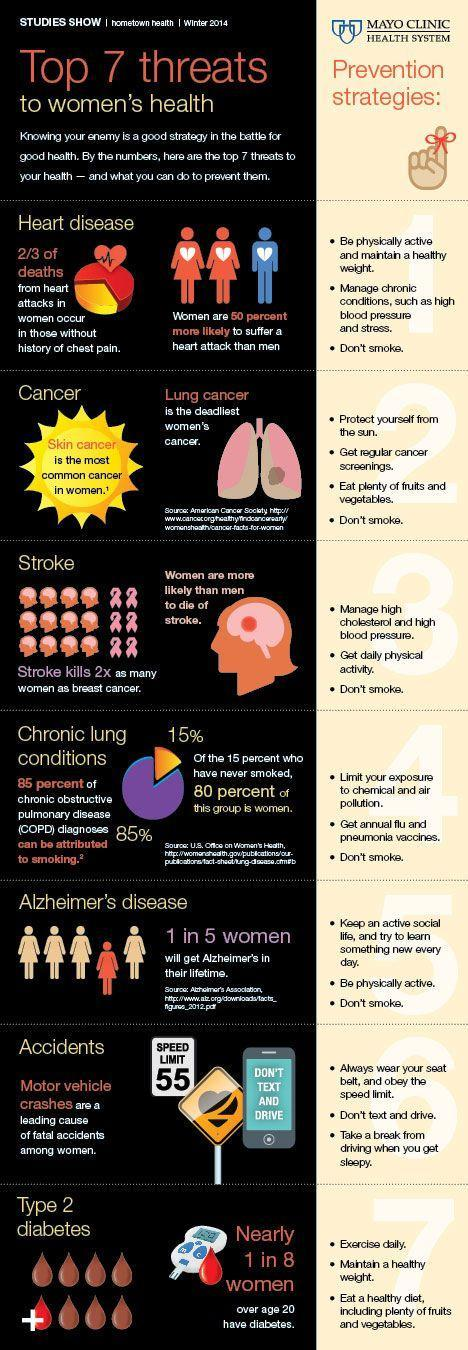Which two diseases are caused due to lack of a healthy diet?
Answer the question with a short phrase. Cancer, Type 2 diabetes What is the common cause of five diseases among the 7 threats listed, drinking, smoking, or physical inactivity? smoking 